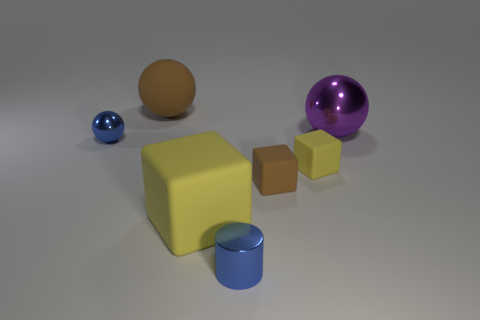Subtract all small blocks. How many blocks are left? 1 Subtract all red balls. How many yellow cubes are left? 2 Subtract all brown cubes. How many cubes are left? 2 Add 1 blue spheres. How many objects exist? 8 Subtract all balls. How many objects are left? 4 Subtract all cyan spheres. Subtract all green cubes. How many spheres are left? 3 Subtract all rubber objects. Subtract all big rubber blocks. How many objects are left? 2 Add 7 tiny yellow matte blocks. How many tiny yellow matte blocks are left? 8 Add 1 blue rubber balls. How many blue rubber balls exist? 1 Subtract 2 yellow cubes. How many objects are left? 5 